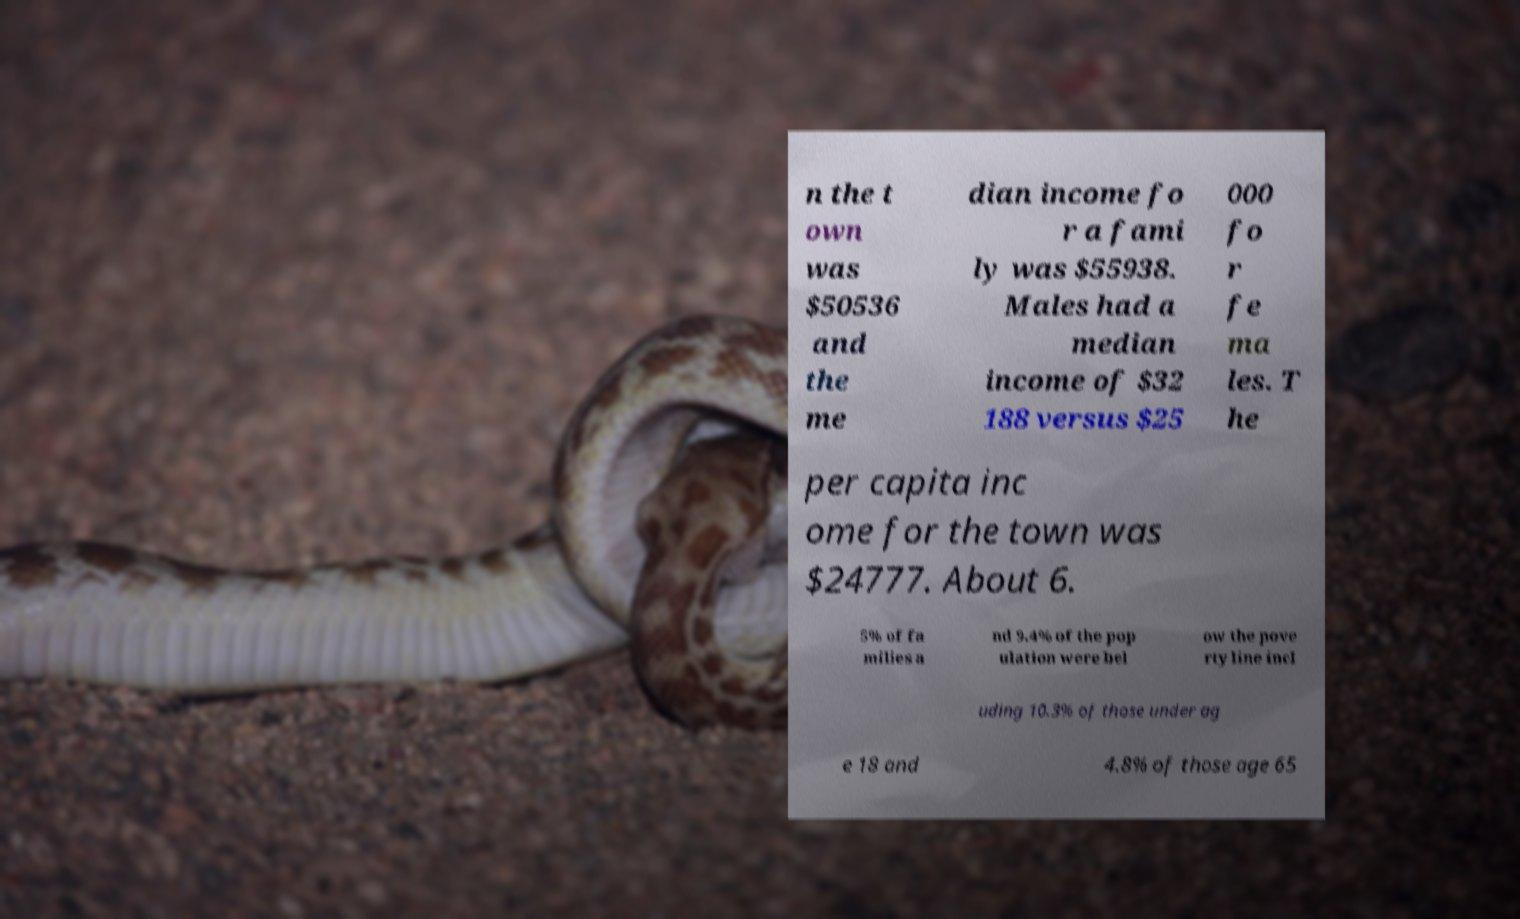I need the written content from this picture converted into text. Can you do that? n the t own was $50536 and the me dian income fo r a fami ly was $55938. Males had a median income of $32 188 versus $25 000 fo r fe ma les. T he per capita inc ome for the town was $24777. About 6. 5% of fa milies a nd 9.4% of the pop ulation were bel ow the pove rty line incl uding 10.3% of those under ag e 18 and 4.8% of those age 65 